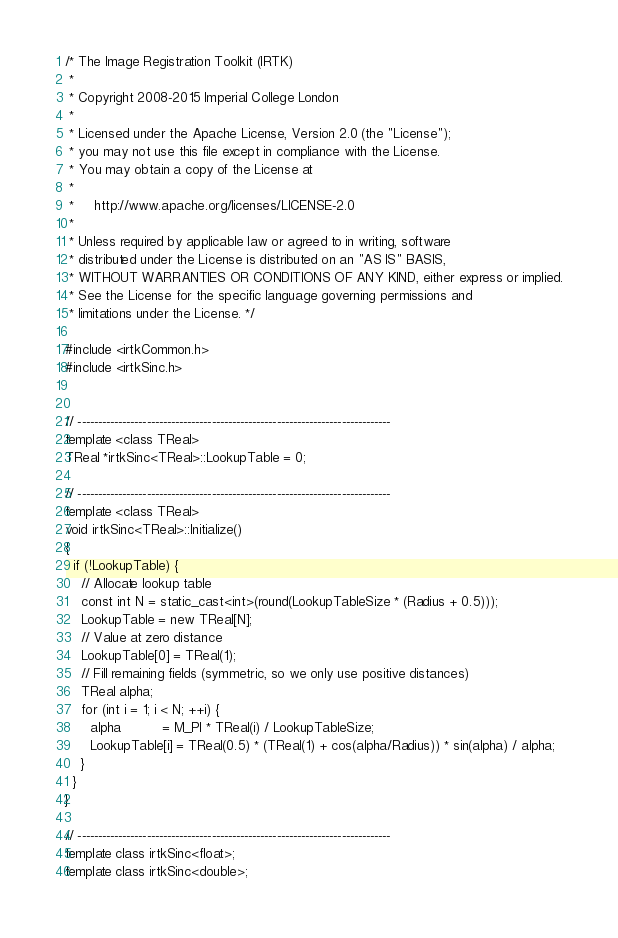<code> <loc_0><loc_0><loc_500><loc_500><_C++_>/* The Image Registration Toolkit (IRTK)
 *
 * Copyright 2008-2015 Imperial College London
 *
 * Licensed under the Apache License, Version 2.0 (the "License");
 * you may not use this file except in compliance with the License.
 * You may obtain a copy of the License at
 *
 *     http://www.apache.org/licenses/LICENSE-2.0
 *
 * Unless required by applicable law or agreed to in writing, software
 * distributed under the License is distributed on an "AS IS" BASIS,
 * WITHOUT WARRANTIES OR CONDITIONS OF ANY KIND, either express or implied.
 * See the License for the specific language governing permissions and
 * limitations under the License. */

#include <irtkCommon.h>
#include <irtkSinc.h>


// -----------------------------------------------------------------------------
template <class TReal>
TReal *irtkSinc<TReal>::LookupTable = 0;

// -----------------------------------------------------------------------------
template <class TReal>
void irtkSinc<TReal>::Initialize()
{
  if (!LookupTable) {
    // Allocate lookup table
    const int N = static_cast<int>(round(LookupTableSize * (Radius + 0.5)));
    LookupTable = new TReal[N];
    // Value at zero distance
    LookupTable[0] = TReal(1);
    // Fill remaining fields (symmetric, so we only use positive distances)
    TReal alpha;
    for (int i = 1; i < N; ++i) {
      alpha          = M_PI * TReal(i) / LookupTableSize;
      LookupTable[i] = TReal(0.5) * (TReal(1) + cos(alpha/Radius)) * sin(alpha) / alpha;
    }
  }
}

// -----------------------------------------------------------------------------
template class irtkSinc<float>;
template class irtkSinc<double>;
</code> 